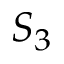Convert formula to latex. <formula><loc_0><loc_0><loc_500><loc_500>S { _ { 3 } }</formula> 